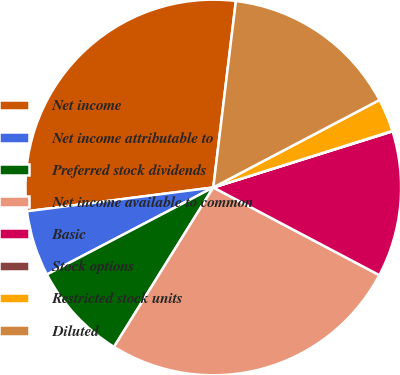Convert chart to OTSL. <chart><loc_0><loc_0><loc_500><loc_500><pie_chart><fcel>Net income<fcel>Net income attributable to<fcel>Preferred stock dividends<fcel>Net income available to common<fcel>Basic<fcel>Stock options<fcel>Restricted stock units<fcel>Diluted<nl><fcel>28.94%<fcel>5.65%<fcel>8.46%<fcel>26.13%<fcel>12.56%<fcel>0.04%<fcel>2.84%<fcel>15.37%<nl></chart> 